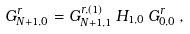Convert formula to latex. <formula><loc_0><loc_0><loc_500><loc_500>G ^ { r } _ { N + 1 , 0 } = G ^ { r , ( 1 ) } _ { N + 1 , 1 } \, H _ { 1 , 0 } \, G ^ { r } _ { 0 , 0 } \, ,</formula> 